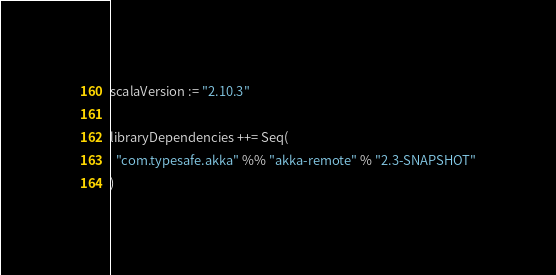Convert code to text. <code><loc_0><loc_0><loc_500><loc_500><_Scala_>scalaVersion := "2.10.3"

libraryDependencies ++= Seq(
  "com.typesafe.akka" %% "akka-remote" % "2.3-SNAPSHOT"
)

</code> 